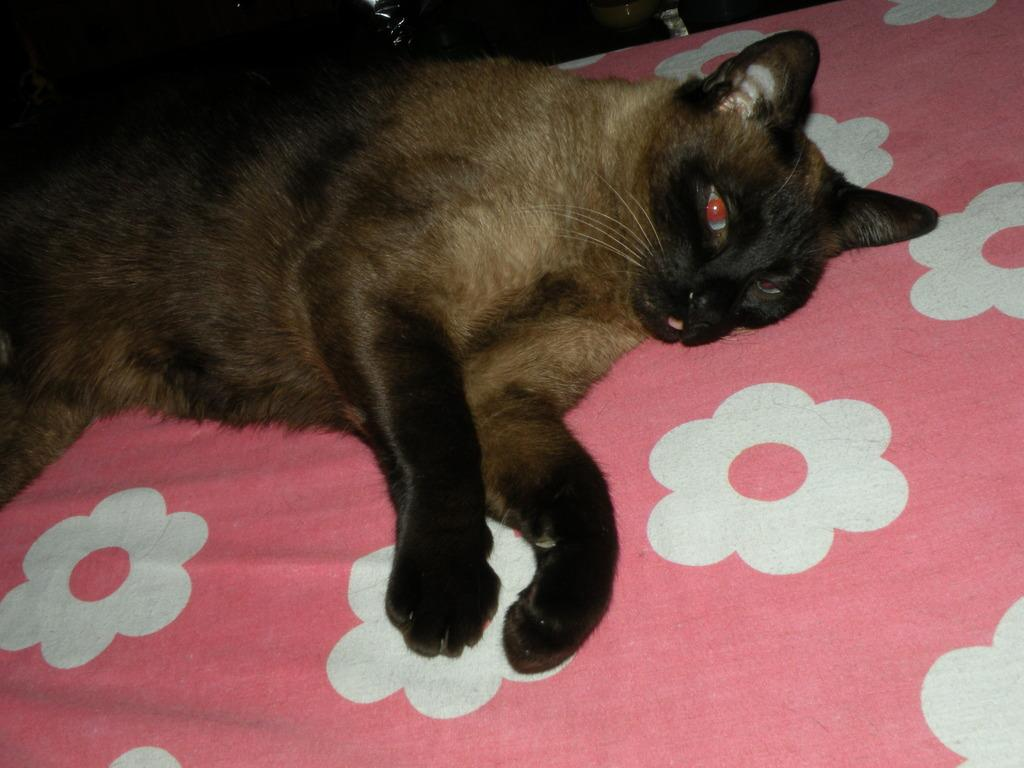What type of animal is in the image? There is a cat in the image. Where is the cat located? The cat is on a bed. What type of sail can be seen in the image? There is no sail present in the image; it features a cat on a bed. How does the glue help the cat in the image? There is no glue present in the image, and therefore it cannot help the cat in any way. 